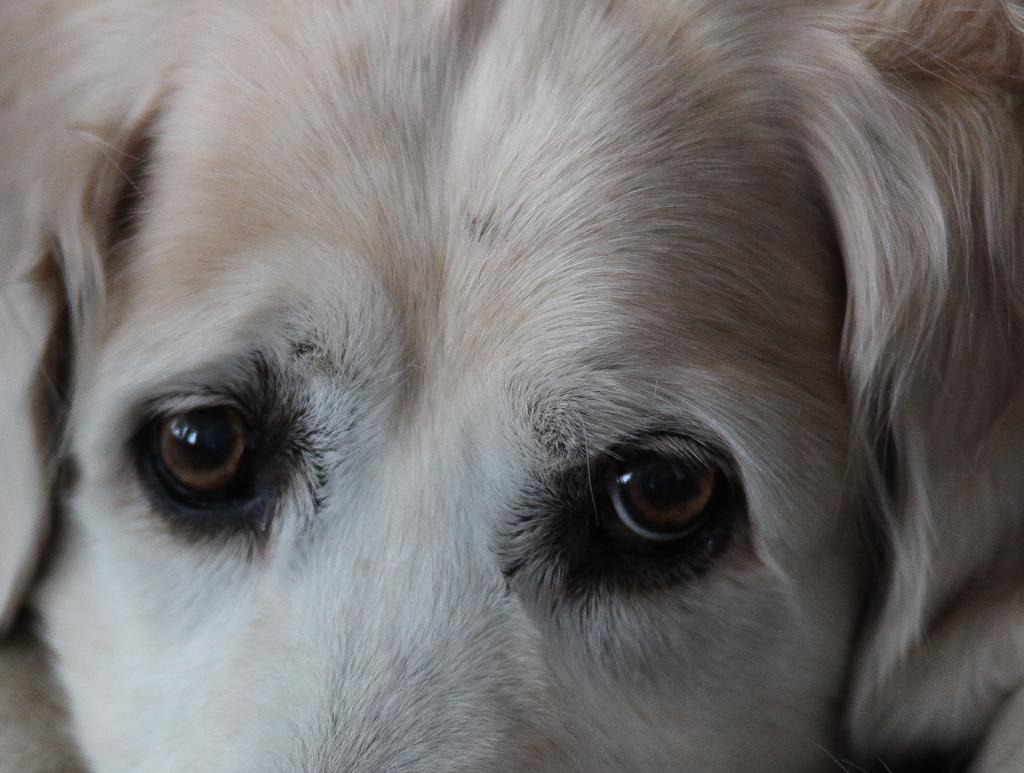What type of living organism can be seen in the image? There is an animal visible in the image. Where is the park located in the image? There is no park present in the image. How many bikes can be seen in the image? There is no mention of bikes in the image. What type of shoe is the animal wearing in the image? There is no shoe present in the image, as animals do not wear shoes. 